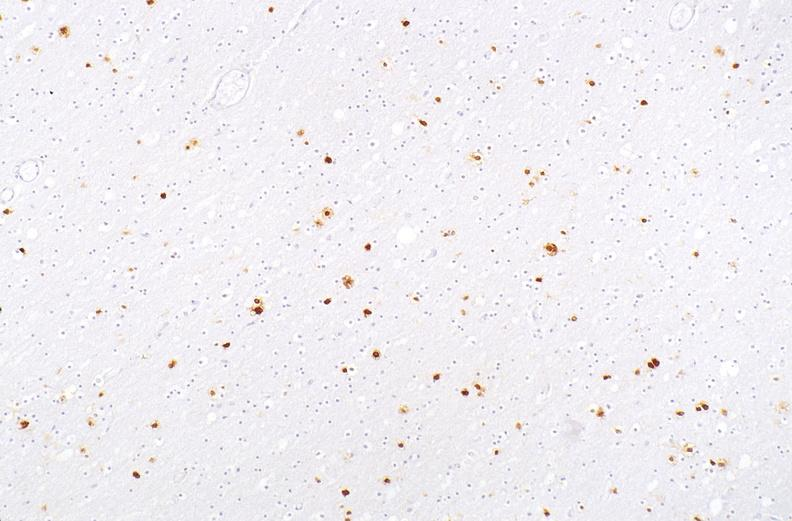what does this image show?
Answer the question using a single word or phrase. Herpes simplex virus 